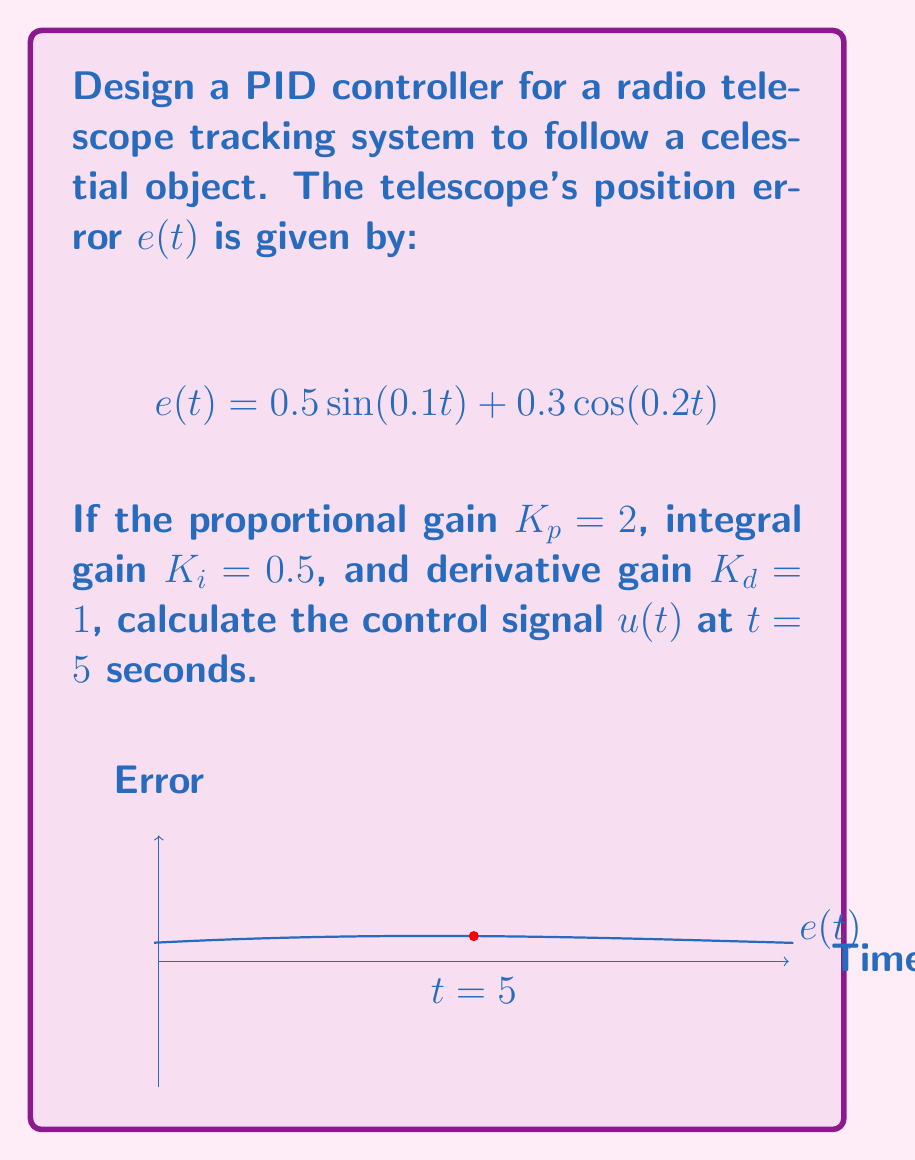Help me with this question. To solve this problem, we'll follow these steps:

1) Recall the PID controller equation:
   $$u(t) = K_p e(t) + K_i \int_0^t e(\tau) d\tau + K_d \frac{de(t)}{dt}$$

2) Calculate $e(t)$ at $t = 5$:
   $$e(5) = 0.5\sin(0.5) + 0.3\cos(1) = 0.2419 + 0.2225 = 0.4644$$

3) Calculate $\int_0^t e(\tau) d\tau$ at $t = 5$:
   $$\int_0^5 e(\tau) d\tau = \int_0^5 (0.5\sin(0.1\tau) + 0.3\cos(0.2\tau)) d\tau$$
   $$= -5\cos(0.1\tau)|_0^5 + 1.5\sin(0.2\tau)|_0^5$$
   $$= -5(\cos(0.5) - 1) + 1.5(\sin(1) - 0) = 0.4796 + 1.2647 = 1.7443$$

4) Calculate $\frac{de(t)}{dt}$ at $t = 5$:
   $$\frac{de(t)}{dt} = 0.05\cos(0.1t) - 0.06\sin(0.2t)$$
   $$\frac{de(5)}{dt} = 0.05\cos(0.5) - 0.06\sin(1) = 0.0429 - 0.0569 = -0.0140$$

5) Substitute these values into the PID controller equation:
   $$u(5) = 2(0.4644) + 0.5(1.7443) + 1(-0.0140)$$
   $$u(5) = 0.9288 + 0.8722 - 0.0140 = 1.7870$$
Answer: $1.7870$ 